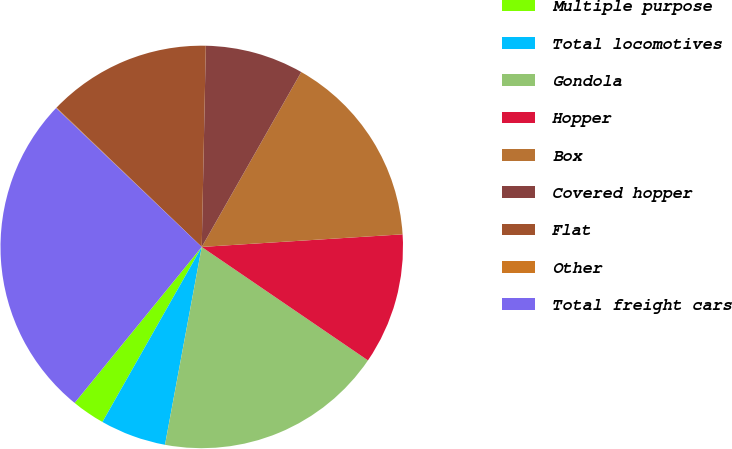Convert chart to OTSL. <chart><loc_0><loc_0><loc_500><loc_500><pie_chart><fcel>Multiple purpose<fcel>Total locomotives<fcel>Gondola<fcel>Hopper<fcel>Box<fcel>Covered hopper<fcel>Flat<fcel>Other<fcel>Total freight cars<nl><fcel>2.67%<fcel>5.29%<fcel>18.39%<fcel>10.53%<fcel>15.77%<fcel>7.91%<fcel>13.15%<fcel>0.05%<fcel>26.24%<nl></chart> 